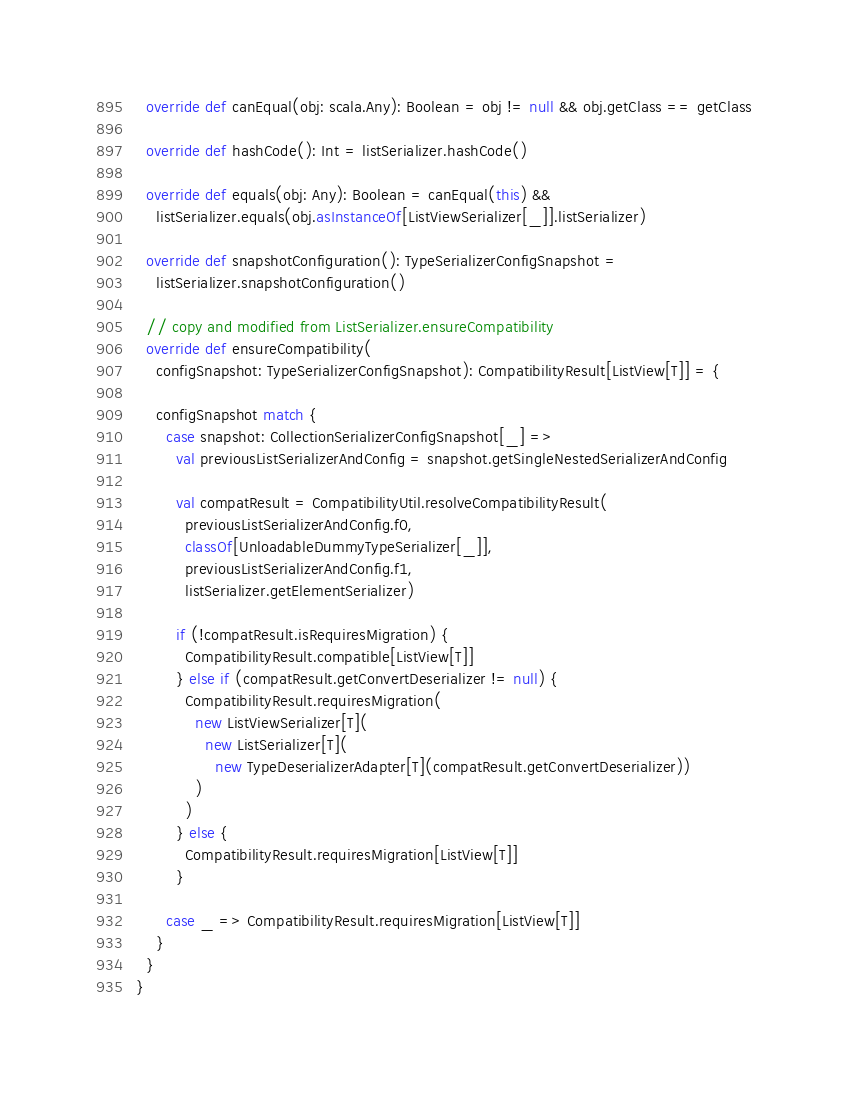Convert code to text. <code><loc_0><loc_0><loc_500><loc_500><_Scala_>
  override def canEqual(obj: scala.Any): Boolean = obj != null && obj.getClass == getClass

  override def hashCode(): Int = listSerializer.hashCode()

  override def equals(obj: Any): Boolean = canEqual(this) &&
    listSerializer.equals(obj.asInstanceOf[ListViewSerializer[_]].listSerializer)

  override def snapshotConfiguration(): TypeSerializerConfigSnapshot =
    listSerializer.snapshotConfiguration()

  // copy and modified from ListSerializer.ensureCompatibility
  override def ensureCompatibility(
    configSnapshot: TypeSerializerConfigSnapshot): CompatibilityResult[ListView[T]] = {

    configSnapshot match {
      case snapshot: CollectionSerializerConfigSnapshot[_] =>
        val previousListSerializerAndConfig = snapshot.getSingleNestedSerializerAndConfig

        val compatResult = CompatibilityUtil.resolveCompatibilityResult(
          previousListSerializerAndConfig.f0,
          classOf[UnloadableDummyTypeSerializer[_]],
          previousListSerializerAndConfig.f1,
          listSerializer.getElementSerializer)

        if (!compatResult.isRequiresMigration) {
          CompatibilityResult.compatible[ListView[T]]
        } else if (compatResult.getConvertDeserializer != null) {
          CompatibilityResult.requiresMigration(
            new ListViewSerializer[T](
              new ListSerializer[T](
                new TypeDeserializerAdapter[T](compatResult.getConvertDeserializer))
            )
          )
        } else {
          CompatibilityResult.requiresMigration[ListView[T]]
        }

      case _ => CompatibilityResult.requiresMigration[ListView[T]]
    }
  }
}
</code> 